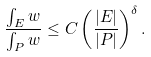Convert formula to latex. <formula><loc_0><loc_0><loc_500><loc_500>\frac { \int _ { E } w } { \int _ { P } w } \leq C \left ( \frac { | E | } { | P | } \right ) ^ { \delta } .</formula> 